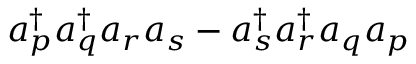Convert formula to latex. <formula><loc_0><loc_0><loc_500><loc_500>a _ { p } ^ { \dagger } a _ { q } ^ { \dagger } a _ { r } a _ { s } - a _ { s } ^ { \dagger } a _ { r } ^ { \dagger } a _ { q } a _ { p }</formula> 